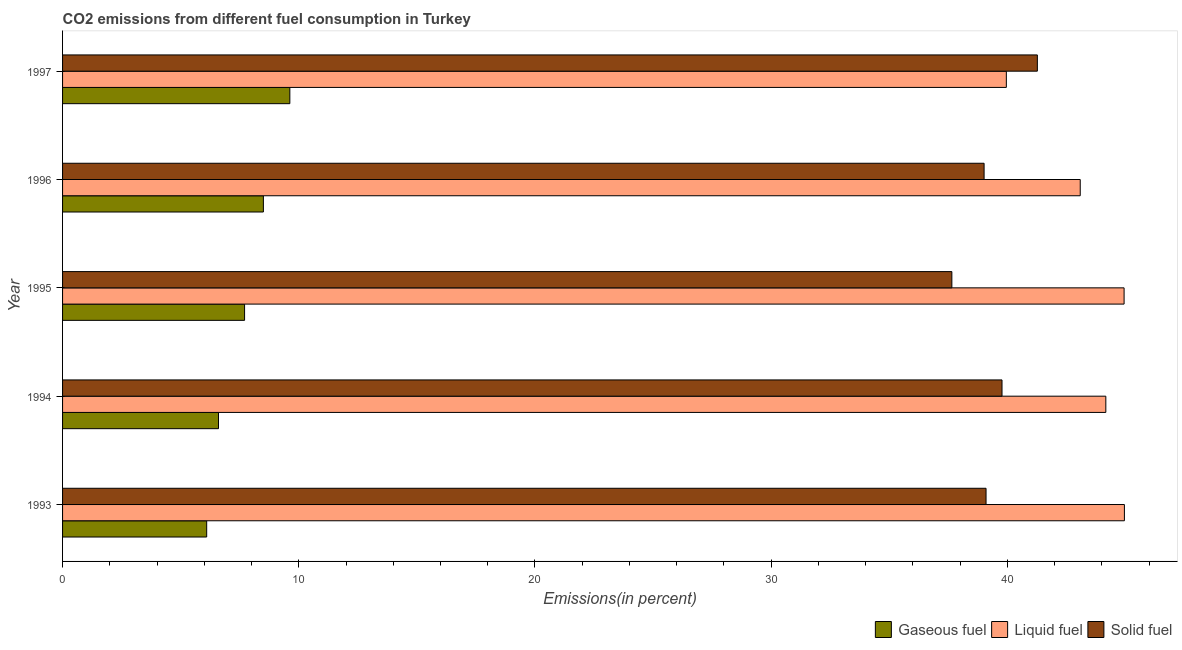How many different coloured bars are there?
Give a very brief answer. 3. How many groups of bars are there?
Provide a short and direct response. 5. Are the number of bars on each tick of the Y-axis equal?
Keep it short and to the point. Yes. How many bars are there on the 5th tick from the bottom?
Provide a succinct answer. 3. In how many cases, is the number of bars for a given year not equal to the number of legend labels?
Keep it short and to the point. 0. What is the percentage of gaseous fuel emission in 1997?
Offer a very short reply. 9.62. Across all years, what is the maximum percentage of solid fuel emission?
Offer a very short reply. 41.27. Across all years, what is the minimum percentage of solid fuel emission?
Keep it short and to the point. 37.65. In which year was the percentage of solid fuel emission maximum?
Your answer should be very brief. 1997. What is the total percentage of solid fuel emission in the graph?
Keep it short and to the point. 196.82. What is the difference between the percentage of solid fuel emission in 1996 and that in 1997?
Your answer should be very brief. -2.25. What is the difference between the percentage of solid fuel emission in 1996 and the percentage of gaseous fuel emission in 1993?
Keep it short and to the point. 32.92. What is the average percentage of gaseous fuel emission per year?
Your answer should be compact. 7.71. In the year 1996, what is the difference between the percentage of gaseous fuel emission and percentage of liquid fuel emission?
Offer a very short reply. -34.58. Is the percentage of liquid fuel emission in 1995 less than that in 1996?
Provide a succinct answer. No. Is the difference between the percentage of solid fuel emission in 1994 and 1996 greater than the difference between the percentage of gaseous fuel emission in 1994 and 1996?
Offer a very short reply. Yes. What is the difference between the highest and the second highest percentage of solid fuel emission?
Your answer should be very brief. 1.5. What is the difference between the highest and the lowest percentage of gaseous fuel emission?
Offer a very short reply. 3.52. What does the 3rd bar from the top in 1995 represents?
Offer a very short reply. Gaseous fuel. What does the 2nd bar from the bottom in 1993 represents?
Offer a very short reply. Liquid fuel. Is it the case that in every year, the sum of the percentage of gaseous fuel emission and percentage of liquid fuel emission is greater than the percentage of solid fuel emission?
Your answer should be very brief. Yes. Are all the bars in the graph horizontal?
Your answer should be very brief. Yes. How many years are there in the graph?
Provide a short and direct response. 5. Does the graph contain any zero values?
Keep it short and to the point. No. What is the title of the graph?
Your answer should be compact. CO2 emissions from different fuel consumption in Turkey. What is the label or title of the X-axis?
Provide a short and direct response. Emissions(in percent). What is the Emissions(in percent) of Gaseous fuel in 1993?
Provide a short and direct response. 6.1. What is the Emissions(in percent) of Liquid fuel in 1993?
Offer a very short reply. 44.96. What is the Emissions(in percent) of Solid fuel in 1993?
Make the answer very short. 39.1. What is the Emissions(in percent) of Gaseous fuel in 1994?
Your answer should be compact. 6.6. What is the Emissions(in percent) in Liquid fuel in 1994?
Offer a very short reply. 44.17. What is the Emissions(in percent) of Solid fuel in 1994?
Give a very brief answer. 39.78. What is the Emissions(in percent) of Gaseous fuel in 1995?
Make the answer very short. 7.71. What is the Emissions(in percent) in Liquid fuel in 1995?
Your response must be concise. 44.94. What is the Emissions(in percent) in Solid fuel in 1995?
Your response must be concise. 37.65. What is the Emissions(in percent) of Gaseous fuel in 1996?
Provide a succinct answer. 8.5. What is the Emissions(in percent) of Liquid fuel in 1996?
Provide a succinct answer. 43.09. What is the Emissions(in percent) in Solid fuel in 1996?
Provide a short and direct response. 39.02. What is the Emissions(in percent) of Gaseous fuel in 1997?
Make the answer very short. 9.62. What is the Emissions(in percent) of Liquid fuel in 1997?
Give a very brief answer. 39.96. What is the Emissions(in percent) of Solid fuel in 1997?
Provide a succinct answer. 41.27. Across all years, what is the maximum Emissions(in percent) of Gaseous fuel?
Provide a succinct answer. 9.62. Across all years, what is the maximum Emissions(in percent) in Liquid fuel?
Make the answer very short. 44.96. Across all years, what is the maximum Emissions(in percent) of Solid fuel?
Your answer should be very brief. 41.27. Across all years, what is the minimum Emissions(in percent) of Gaseous fuel?
Give a very brief answer. 6.1. Across all years, what is the minimum Emissions(in percent) in Liquid fuel?
Ensure brevity in your answer.  39.96. Across all years, what is the minimum Emissions(in percent) of Solid fuel?
Your answer should be compact. 37.65. What is the total Emissions(in percent) of Gaseous fuel in the graph?
Ensure brevity in your answer.  38.54. What is the total Emissions(in percent) in Liquid fuel in the graph?
Ensure brevity in your answer.  217.12. What is the total Emissions(in percent) of Solid fuel in the graph?
Offer a very short reply. 196.82. What is the difference between the Emissions(in percent) of Gaseous fuel in 1993 and that in 1994?
Your answer should be compact. -0.5. What is the difference between the Emissions(in percent) of Liquid fuel in 1993 and that in 1994?
Make the answer very short. 0.79. What is the difference between the Emissions(in percent) of Solid fuel in 1993 and that in 1994?
Ensure brevity in your answer.  -0.68. What is the difference between the Emissions(in percent) of Gaseous fuel in 1993 and that in 1995?
Offer a very short reply. -1.6. What is the difference between the Emissions(in percent) of Liquid fuel in 1993 and that in 1995?
Keep it short and to the point. 0.01. What is the difference between the Emissions(in percent) in Solid fuel in 1993 and that in 1995?
Keep it short and to the point. 1.45. What is the difference between the Emissions(in percent) in Gaseous fuel in 1993 and that in 1996?
Offer a terse response. -2.4. What is the difference between the Emissions(in percent) in Liquid fuel in 1993 and that in 1996?
Provide a short and direct response. 1.87. What is the difference between the Emissions(in percent) of Solid fuel in 1993 and that in 1996?
Your response must be concise. 0.08. What is the difference between the Emissions(in percent) in Gaseous fuel in 1993 and that in 1997?
Make the answer very short. -3.52. What is the difference between the Emissions(in percent) in Liquid fuel in 1993 and that in 1997?
Keep it short and to the point. 5. What is the difference between the Emissions(in percent) of Solid fuel in 1993 and that in 1997?
Provide a succinct answer. -2.17. What is the difference between the Emissions(in percent) of Gaseous fuel in 1994 and that in 1995?
Make the answer very short. -1.1. What is the difference between the Emissions(in percent) in Liquid fuel in 1994 and that in 1995?
Your response must be concise. -0.77. What is the difference between the Emissions(in percent) of Solid fuel in 1994 and that in 1995?
Offer a terse response. 2.12. What is the difference between the Emissions(in percent) of Gaseous fuel in 1994 and that in 1996?
Provide a succinct answer. -1.9. What is the difference between the Emissions(in percent) in Solid fuel in 1994 and that in 1996?
Give a very brief answer. 0.76. What is the difference between the Emissions(in percent) in Gaseous fuel in 1994 and that in 1997?
Offer a very short reply. -3.02. What is the difference between the Emissions(in percent) in Liquid fuel in 1994 and that in 1997?
Give a very brief answer. 4.21. What is the difference between the Emissions(in percent) of Solid fuel in 1994 and that in 1997?
Provide a short and direct response. -1.5. What is the difference between the Emissions(in percent) of Gaseous fuel in 1995 and that in 1996?
Make the answer very short. -0.8. What is the difference between the Emissions(in percent) in Liquid fuel in 1995 and that in 1996?
Offer a very short reply. 1.86. What is the difference between the Emissions(in percent) in Solid fuel in 1995 and that in 1996?
Provide a succinct answer. -1.36. What is the difference between the Emissions(in percent) in Gaseous fuel in 1995 and that in 1997?
Provide a succinct answer. -1.92. What is the difference between the Emissions(in percent) in Liquid fuel in 1995 and that in 1997?
Provide a succinct answer. 4.99. What is the difference between the Emissions(in percent) of Solid fuel in 1995 and that in 1997?
Provide a succinct answer. -3.62. What is the difference between the Emissions(in percent) of Gaseous fuel in 1996 and that in 1997?
Offer a terse response. -1.12. What is the difference between the Emissions(in percent) of Liquid fuel in 1996 and that in 1997?
Your response must be concise. 3.13. What is the difference between the Emissions(in percent) in Solid fuel in 1996 and that in 1997?
Offer a terse response. -2.25. What is the difference between the Emissions(in percent) in Gaseous fuel in 1993 and the Emissions(in percent) in Liquid fuel in 1994?
Ensure brevity in your answer.  -38.07. What is the difference between the Emissions(in percent) in Gaseous fuel in 1993 and the Emissions(in percent) in Solid fuel in 1994?
Your answer should be very brief. -33.67. What is the difference between the Emissions(in percent) in Liquid fuel in 1993 and the Emissions(in percent) in Solid fuel in 1994?
Make the answer very short. 5.18. What is the difference between the Emissions(in percent) in Gaseous fuel in 1993 and the Emissions(in percent) in Liquid fuel in 1995?
Your answer should be very brief. -38.84. What is the difference between the Emissions(in percent) of Gaseous fuel in 1993 and the Emissions(in percent) of Solid fuel in 1995?
Provide a short and direct response. -31.55. What is the difference between the Emissions(in percent) of Liquid fuel in 1993 and the Emissions(in percent) of Solid fuel in 1995?
Your response must be concise. 7.31. What is the difference between the Emissions(in percent) in Gaseous fuel in 1993 and the Emissions(in percent) in Liquid fuel in 1996?
Provide a succinct answer. -36.99. What is the difference between the Emissions(in percent) in Gaseous fuel in 1993 and the Emissions(in percent) in Solid fuel in 1996?
Make the answer very short. -32.91. What is the difference between the Emissions(in percent) of Liquid fuel in 1993 and the Emissions(in percent) of Solid fuel in 1996?
Keep it short and to the point. 5.94. What is the difference between the Emissions(in percent) in Gaseous fuel in 1993 and the Emissions(in percent) in Liquid fuel in 1997?
Your response must be concise. -33.86. What is the difference between the Emissions(in percent) in Gaseous fuel in 1993 and the Emissions(in percent) in Solid fuel in 1997?
Offer a terse response. -35.17. What is the difference between the Emissions(in percent) of Liquid fuel in 1993 and the Emissions(in percent) of Solid fuel in 1997?
Keep it short and to the point. 3.69. What is the difference between the Emissions(in percent) of Gaseous fuel in 1994 and the Emissions(in percent) of Liquid fuel in 1995?
Keep it short and to the point. -38.34. What is the difference between the Emissions(in percent) of Gaseous fuel in 1994 and the Emissions(in percent) of Solid fuel in 1995?
Provide a short and direct response. -31.05. What is the difference between the Emissions(in percent) of Liquid fuel in 1994 and the Emissions(in percent) of Solid fuel in 1995?
Your answer should be very brief. 6.52. What is the difference between the Emissions(in percent) of Gaseous fuel in 1994 and the Emissions(in percent) of Liquid fuel in 1996?
Provide a short and direct response. -36.48. What is the difference between the Emissions(in percent) in Gaseous fuel in 1994 and the Emissions(in percent) in Solid fuel in 1996?
Make the answer very short. -32.41. What is the difference between the Emissions(in percent) in Liquid fuel in 1994 and the Emissions(in percent) in Solid fuel in 1996?
Offer a very short reply. 5.15. What is the difference between the Emissions(in percent) in Gaseous fuel in 1994 and the Emissions(in percent) in Liquid fuel in 1997?
Your answer should be compact. -33.36. What is the difference between the Emissions(in percent) in Gaseous fuel in 1994 and the Emissions(in percent) in Solid fuel in 1997?
Offer a very short reply. -34.67. What is the difference between the Emissions(in percent) of Liquid fuel in 1994 and the Emissions(in percent) of Solid fuel in 1997?
Provide a succinct answer. 2.9. What is the difference between the Emissions(in percent) in Gaseous fuel in 1995 and the Emissions(in percent) in Liquid fuel in 1996?
Provide a short and direct response. -35.38. What is the difference between the Emissions(in percent) in Gaseous fuel in 1995 and the Emissions(in percent) in Solid fuel in 1996?
Your response must be concise. -31.31. What is the difference between the Emissions(in percent) of Liquid fuel in 1995 and the Emissions(in percent) of Solid fuel in 1996?
Your answer should be very brief. 5.93. What is the difference between the Emissions(in percent) of Gaseous fuel in 1995 and the Emissions(in percent) of Liquid fuel in 1997?
Provide a short and direct response. -32.25. What is the difference between the Emissions(in percent) in Gaseous fuel in 1995 and the Emissions(in percent) in Solid fuel in 1997?
Your response must be concise. -33.57. What is the difference between the Emissions(in percent) in Liquid fuel in 1995 and the Emissions(in percent) in Solid fuel in 1997?
Make the answer very short. 3.67. What is the difference between the Emissions(in percent) of Gaseous fuel in 1996 and the Emissions(in percent) of Liquid fuel in 1997?
Provide a succinct answer. -31.46. What is the difference between the Emissions(in percent) in Gaseous fuel in 1996 and the Emissions(in percent) in Solid fuel in 1997?
Make the answer very short. -32.77. What is the difference between the Emissions(in percent) in Liquid fuel in 1996 and the Emissions(in percent) in Solid fuel in 1997?
Your response must be concise. 1.82. What is the average Emissions(in percent) of Gaseous fuel per year?
Your answer should be compact. 7.71. What is the average Emissions(in percent) in Liquid fuel per year?
Provide a short and direct response. 43.42. What is the average Emissions(in percent) in Solid fuel per year?
Make the answer very short. 39.36. In the year 1993, what is the difference between the Emissions(in percent) in Gaseous fuel and Emissions(in percent) in Liquid fuel?
Make the answer very short. -38.86. In the year 1993, what is the difference between the Emissions(in percent) in Gaseous fuel and Emissions(in percent) in Solid fuel?
Provide a short and direct response. -33. In the year 1993, what is the difference between the Emissions(in percent) of Liquid fuel and Emissions(in percent) of Solid fuel?
Ensure brevity in your answer.  5.86. In the year 1994, what is the difference between the Emissions(in percent) in Gaseous fuel and Emissions(in percent) in Liquid fuel?
Offer a very short reply. -37.57. In the year 1994, what is the difference between the Emissions(in percent) of Gaseous fuel and Emissions(in percent) of Solid fuel?
Make the answer very short. -33.17. In the year 1994, what is the difference between the Emissions(in percent) of Liquid fuel and Emissions(in percent) of Solid fuel?
Offer a very short reply. 4.4. In the year 1995, what is the difference between the Emissions(in percent) of Gaseous fuel and Emissions(in percent) of Liquid fuel?
Keep it short and to the point. -37.24. In the year 1995, what is the difference between the Emissions(in percent) in Gaseous fuel and Emissions(in percent) in Solid fuel?
Your answer should be compact. -29.95. In the year 1995, what is the difference between the Emissions(in percent) of Liquid fuel and Emissions(in percent) of Solid fuel?
Your answer should be very brief. 7.29. In the year 1996, what is the difference between the Emissions(in percent) in Gaseous fuel and Emissions(in percent) in Liquid fuel?
Offer a very short reply. -34.58. In the year 1996, what is the difference between the Emissions(in percent) of Gaseous fuel and Emissions(in percent) of Solid fuel?
Provide a succinct answer. -30.51. In the year 1996, what is the difference between the Emissions(in percent) in Liquid fuel and Emissions(in percent) in Solid fuel?
Give a very brief answer. 4.07. In the year 1997, what is the difference between the Emissions(in percent) of Gaseous fuel and Emissions(in percent) of Liquid fuel?
Offer a terse response. -30.34. In the year 1997, what is the difference between the Emissions(in percent) of Gaseous fuel and Emissions(in percent) of Solid fuel?
Provide a short and direct response. -31.65. In the year 1997, what is the difference between the Emissions(in percent) of Liquid fuel and Emissions(in percent) of Solid fuel?
Offer a terse response. -1.31. What is the ratio of the Emissions(in percent) of Gaseous fuel in 1993 to that in 1994?
Your answer should be very brief. 0.92. What is the ratio of the Emissions(in percent) of Liquid fuel in 1993 to that in 1994?
Give a very brief answer. 1.02. What is the ratio of the Emissions(in percent) in Solid fuel in 1993 to that in 1994?
Offer a terse response. 0.98. What is the ratio of the Emissions(in percent) in Gaseous fuel in 1993 to that in 1995?
Your answer should be very brief. 0.79. What is the ratio of the Emissions(in percent) of Solid fuel in 1993 to that in 1995?
Keep it short and to the point. 1.04. What is the ratio of the Emissions(in percent) in Gaseous fuel in 1993 to that in 1996?
Your response must be concise. 0.72. What is the ratio of the Emissions(in percent) of Liquid fuel in 1993 to that in 1996?
Your response must be concise. 1.04. What is the ratio of the Emissions(in percent) of Gaseous fuel in 1993 to that in 1997?
Keep it short and to the point. 0.63. What is the ratio of the Emissions(in percent) in Liquid fuel in 1993 to that in 1997?
Your response must be concise. 1.13. What is the ratio of the Emissions(in percent) in Solid fuel in 1993 to that in 1997?
Your response must be concise. 0.95. What is the ratio of the Emissions(in percent) in Gaseous fuel in 1994 to that in 1995?
Keep it short and to the point. 0.86. What is the ratio of the Emissions(in percent) of Liquid fuel in 1994 to that in 1995?
Give a very brief answer. 0.98. What is the ratio of the Emissions(in percent) of Solid fuel in 1994 to that in 1995?
Ensure brevity in your answer.  1.06. What is the ratio of the Emissions(in percent) of Gaseous fuel in 1994 to that in 1996?
Provide a short and direct response. 0.78. What is the ratio of the Emissions(in percent) in Liquid fuel in 1994 to that in 1996?
Offer a terse response. 1.03. What is the ratio of the Emissions(in percent) of Solid fuel in 1994 to that in 1996?
Make the answer very short. 1.02. What is the ratio of the Emissions(in percent) of Gaseous fuel in 1994 to that in 1997?
Your response must be concise. 0.69. What is the ratio of the Emissions(in percent) of Liquid fuel in 1994 to that in 1997?
Your response must be concise. 1.11. What is the ratio of the Emissions(in percent) in Solid fuel in 1994 to that in 1997?
Make the answer very short. 0.96. What is the ratio of the Emissions(in percent) in Gaseous fuel in 1995 to that in 1996?
Your answer should be compact. 0.91. What is the ratio of the Emissions(in percent) in Liquid fuel in 1995 to that in 1996?
Ensure brevity in your answer.  1.04. What is the ratio of the Emissions(in percent) of Gaseous fuel in 1995 to that in 1997?
Offer a terse response. 0.8. What is the ratio of the Emissions(in percent) in Liquid fuel in 1995 to that in 1997?
Your answer should be compact. 1.12. What is the ratio of the Emissions(in percent) in Solid fuel in 1995 to that in 1997?
Your response must be concise. 0.91. What is the ratio of the Emissions(in percent) of Gaseous fuel in 1996 to that in 1997?
Offer a very short reply. 0.88. What is the ratio of the Emissions(in percent) of Liquid fuel in 1996 to that in 1997?
Your answer should be very brief. 1.08. What is the ratio of the Emissions(in percent) of Solid fuel in 1996 to that in 1997?
Give a very brief answer. 0.95. What is the difference between the highest and the second highest Emissions(in percent) of Gaseous fuel?
Your answer should be very brief. 1.12. What is the difference between the highest and the second highest Emissions(in percent) of Liquid fuel?
Your answer should be very brief. 0.01. What is the difference between the highest and the second highest Emissions(in percent) of Solid fuel?
Make the answer very short. 1.5. What is the difference between the highest and the lowest Emissions(in percent) of Gaseous fuel?
Keep it short and to the point. 3.52. What is the difference between the highest and the lowest Emissions(in percent) of Liquid fuel?
Offer a terse response. 5. What is the difference between the highest and the lowest Emissions(in percent) of Solid fuel?
Offer a terse response. 3.62. 